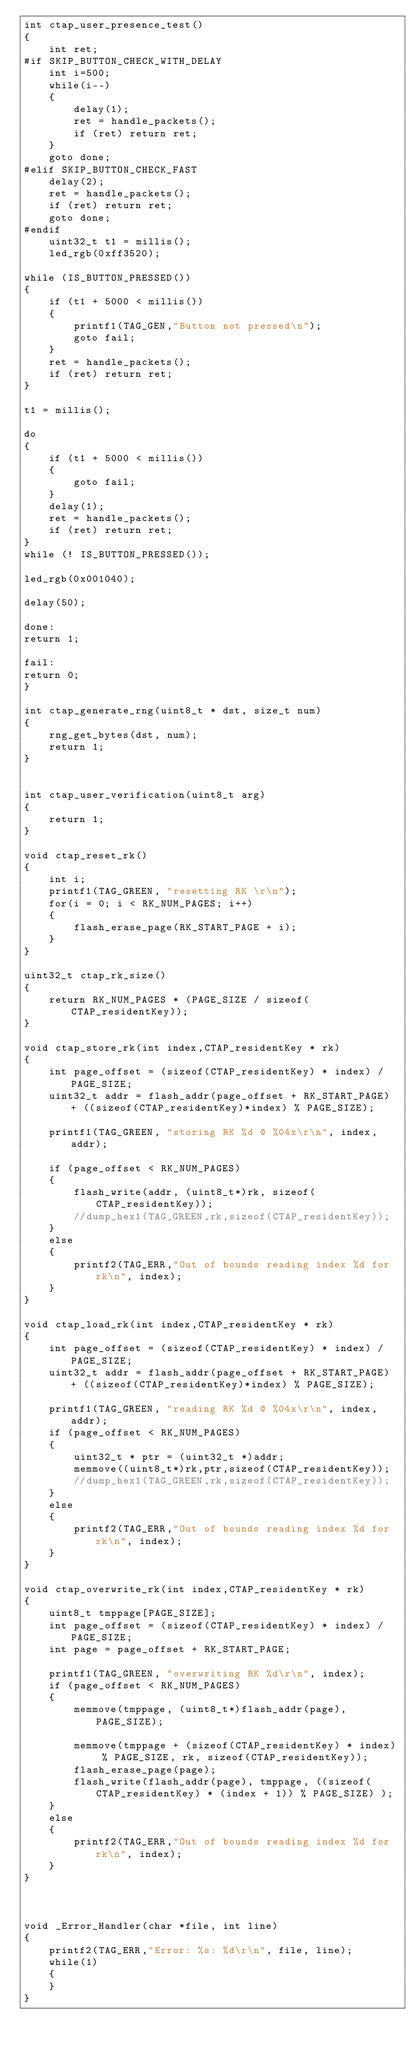Convert code to text. <code><loc_0><loc_0><loc_500><loc_500><_C_>int ctap_user_presence_test()
{
    int ret;
#if SKIP_BUTTON_CHECK_WITH_DELAY
    int i=500;
    while(i--)
    {
        delay(1);
        ret = handle_packets();
        if (ret) return ret;
    }
    goto done;
#elif SKIP_BUTTON_CHECK_FAST
    delay(2);
    ret = handle_packets();
    if (ret) return ret;
    goto done;
#endif
    uint32_t t1 = millis();
    led_rgb(0xff3520);

while (IS_BUTTON_PRESSED())
{
    if (t1 + 5000 < millis())
    {
        printf1(TAG_GEN,"Button not pressed\n");
        goto fail;
    }
    ret = handle_packets();
    if (ret) return ret;
}

t1 = millis();

do
{
    if (t1 + 5000 < millis())
    {
        goto fail;
    }
    delay(1);
    ret = handle_packets();
    if (ret) return ret;
}
while (! IS_BUTTON_PRESSED());

led_rgb(0x001040);

delay(50);

done:
return 1;

fail:
return 0;
}

int ctap_generate_rng(uint8_t * dst, size_t num)
{
    rng_get_bytes(dst, num);
    return 1;
}


int ctap_user_verification(uint8_t arg)
{
    return 1;
}

void ctap_reset_rk()
{
    int i;
    printf1(TAG_GREEN, "resetting RK \r\n");
    for(i = 0; i < RK_NUM_PAGES; i++)
    {
        flash_erase_page(RK_START_PAGE + i);
    }
}

uint32_t ctap_rk_size()
{
    return RK_NUM_PAGES * (PAGE_SIZE / sizeof(CTAP_residentKey));
}

void ctap_store_rk(int index,CTAP_residentKey * rk)
{
    int page_offset = (sizeof(CTAP_residentKey) * index) / PAGE_SIZE;
    uint32_t addr = flash_addr(page_offset + RK_START_PAGE) + ((sizeof(CTAP_residentKey)*index) % PAGE_SIZE);

    printf1(TAG_GREEN, "storing RK %d @ %04x\r\n", index,addr);

    if (page_offset < RK_NUM_PAGES)
    {
        flash_write(addr, (uint8_t*)rk, sizeof(CTAP_residentKey));
        //dump_hex1(TAG_GREEN,rk,sizeof(CTAP_residentKey));
    }
    else
    {
        printf2(TAG_ERR,"Out of bounds reading index %d for rk\n", index);
    }
}

void ctap_load_rk(int index,CTAP_residentKey * rk)
{
    int page_offset = (sizeof(CTAP_residentKey) * index) / PAGE_SIZE;
    uint32_t addr = flash_addr(page_offset + RK_START_PAGE) + ((sizeof(CTAP_residentKey)*index) % PAGE_SIZE);

    printf1(TAG_GREEN, "reading RK %d @ %04x\r\n", index, addr);
    if (page_offset < RK_NUM_PAGES)
    {
        uint32_t * ptr = (uint32_t *)addr;
        memmove((uint8_t*)rk,ptr,sizeof(CTAP_residentKey));
        //dump_hex1(TAG_GREEN,rk,sizeof(CTAP_residentKey));
    }
    else
    {
        printf2(TAG_ERR,"Out of bounds reading index %d for rk\n", index);
    }
}

void ctap_overwrite_rk(int index,CTAP_residentKey * rk)
{
    uint8_t tmppage[PAGE_SIZE];
    int page_offset = (sizeof(CTAP_residentKey) * index) / PAGE_SIZE;
    int page = page_offset + RK_START_PAGE;

    printf1(TAG_GREEN, "overwriting RK %d\r\n", index);
    if (page_offset < RK_NUM_PAGES)
    {
        memmove(tmppage, (uint8_t*)flash_addr(page), PAGE_SIZE);

        memmove(tmppage + (sizeof(CTAP_residentKey) * index) % PAGE_SIZE, rk, sizeof(CTAP_residentKey));
        flash_erase_page(page);
        flash_write(flash_addr(page), tmppage, ((sizeof(CTAP_residentKey) * (index + 1)) % PAGE_SIZE) );
    }
    else
    {
        printf2(TAG_ERR,"Out of bounds reading index %d for rk\n", index);
    }
}



void _Error_Handler(char *file, int line)
{
    printf2(TAG_ERR,"Error: %s: %d\r\n", file, line);
    while(1)
    {
    }
}
</code> 